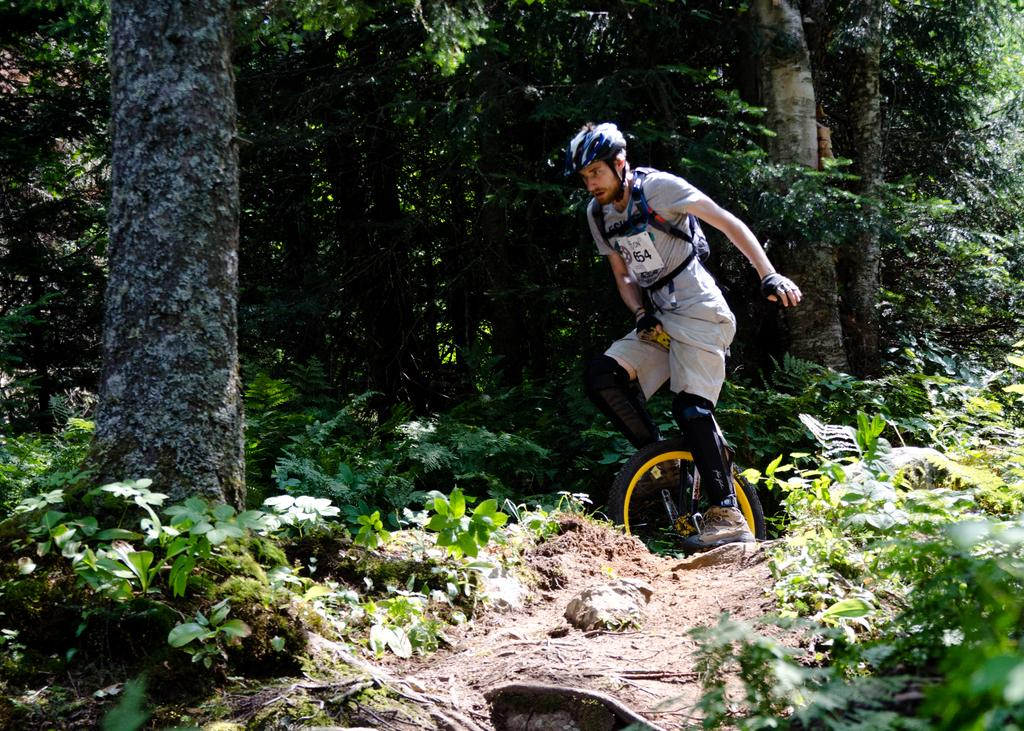What is the person in the image doing? The person is riding a unicycle. What safety precaution is the person taking while riding the unicycle? The person is wearing a helmet. Can you describe the tree in the image? There is a tree with visible bark in the image. What type of vegetation is present in the image? There are plants and a group of trees in the image. How many babies are being carried in a pail in the image? There are no babies or pails present in the image. 